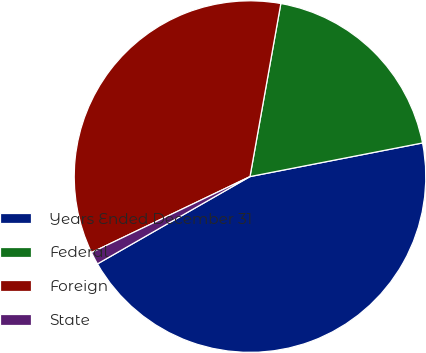Convert chart. <chart><loc_0><loc_0><loc_500><loc_500><pie_chart><fcel>Years Ended December 31<fcel>Federal<fcel>Foreign<fcel>State<nl><fcel>44.79%<fcel>19.13%<fcel>34.92%<fcel>1.16%<nl></chart> 